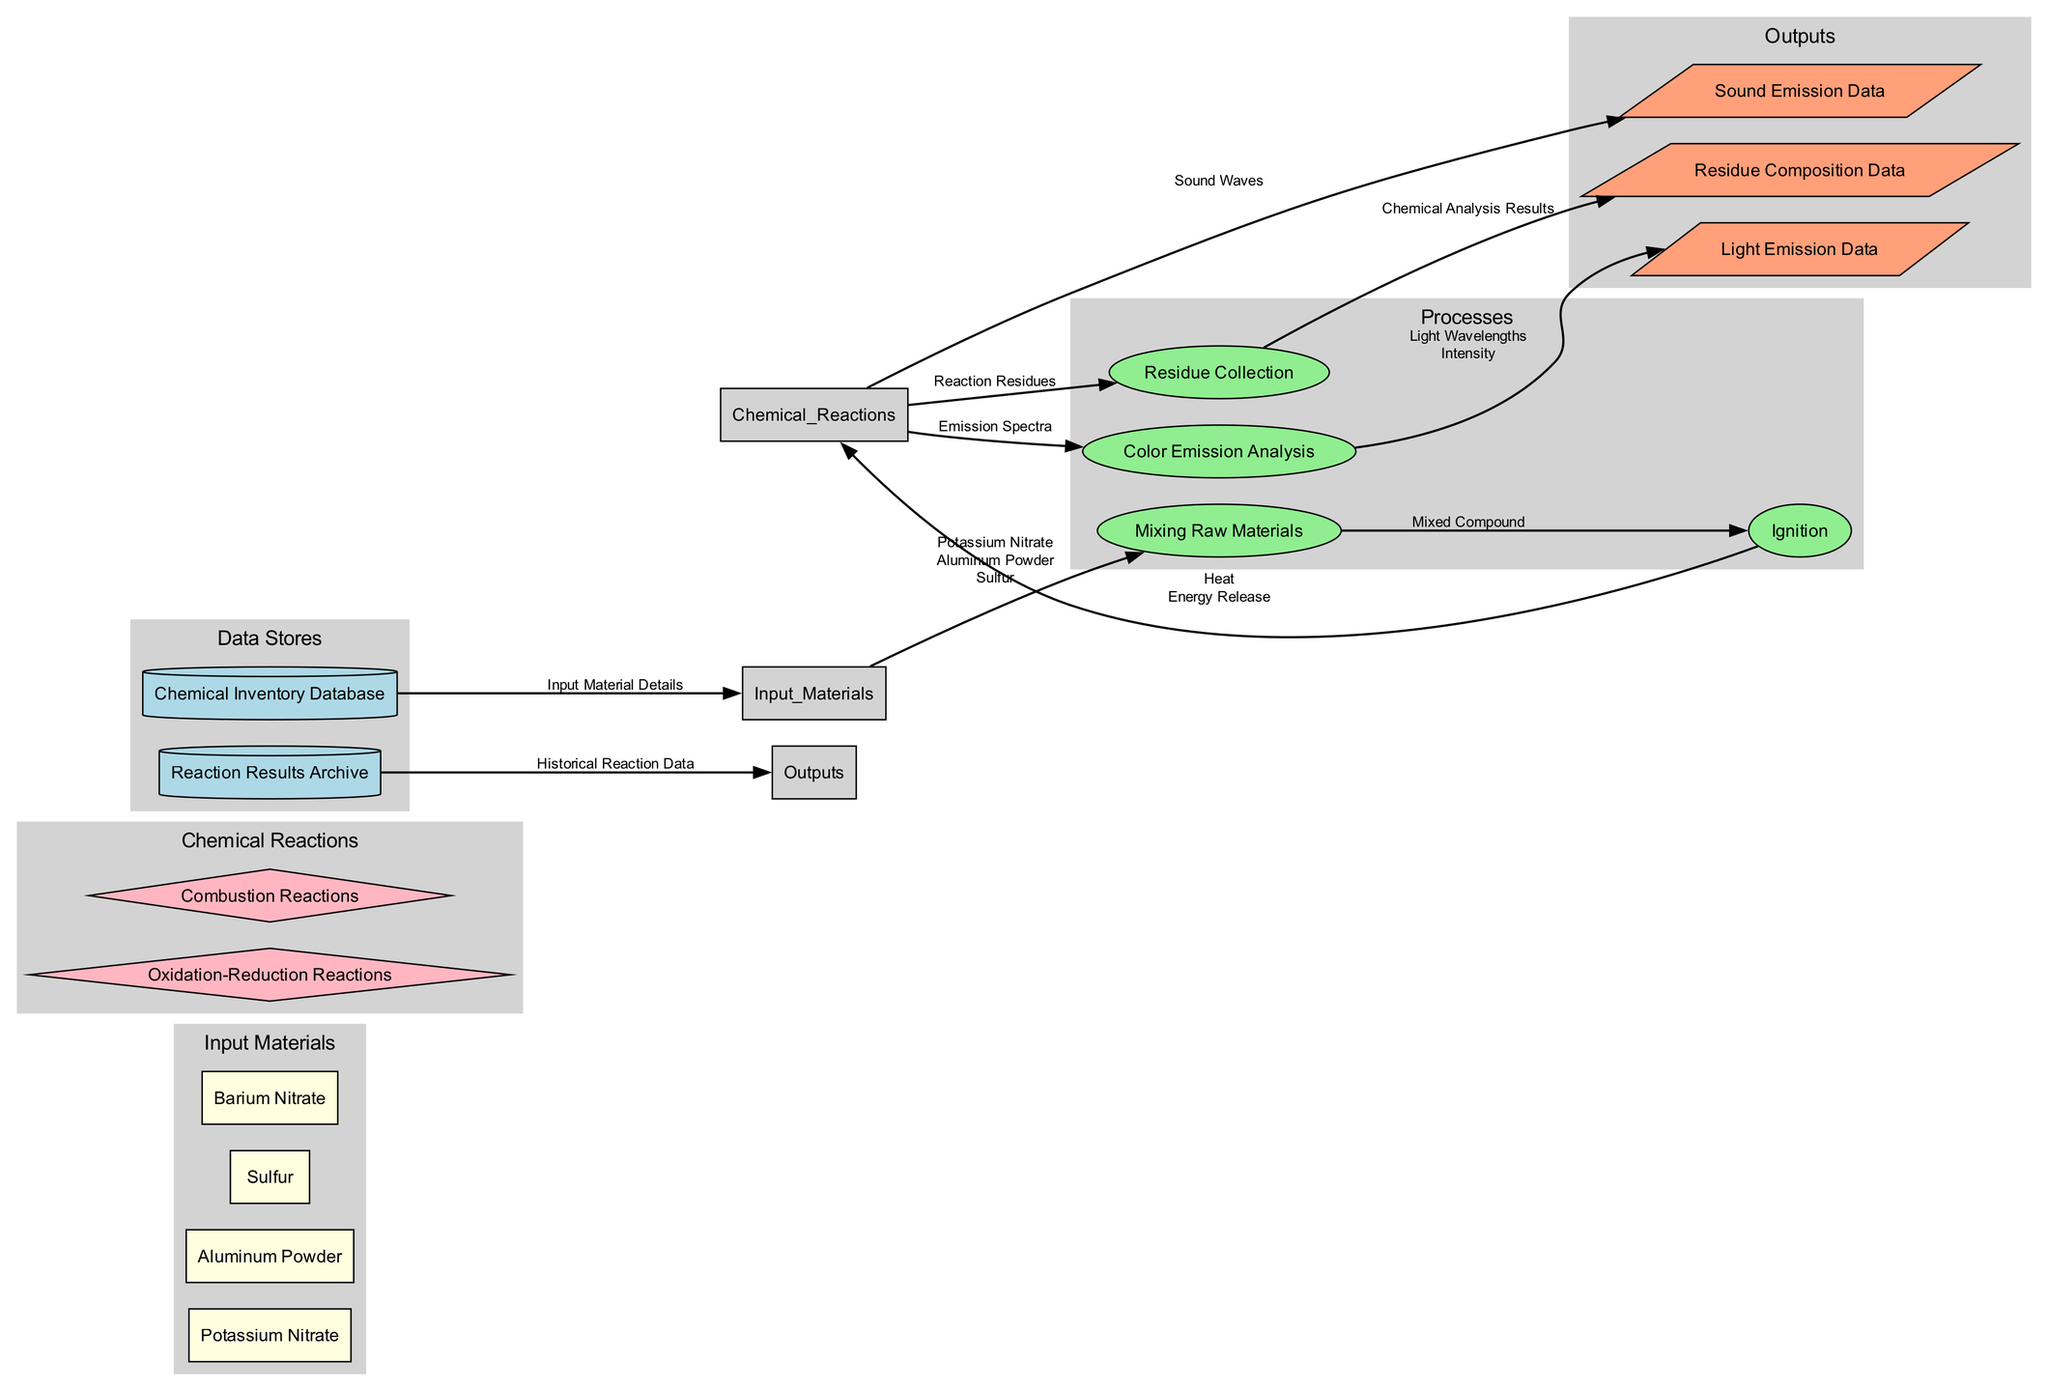What are the input materials used in the fireworks process? The diagram shows four input materials listed as "Potassium Nitrate," "Aluminum Powder," "Sulfur," and "Barium Nitrate" under the Input Materials section.
Answer: Potassium Nitrate, Aluminum Powder, Sulfur, Barium Nitrate Which process comes after "Mixing Raw Materials"? The flow from "Mixing Raw Materials" leads directly to "Ignition," indicating that ignition is the next step after mixing.
Answer: Ignition How many outputs are produced from the chemical reactions? The diagram lists three outputs: "Light Emission Data," "Sound Emission Data," and "Residue Composition Data." Therefore, there are three unique output paths stemming from the reactions.
Answer: Three What kind of data is not stored in the Chemical Inventory Database? The Chemical Inventory Database contains "Input Material Details," which means any data regarding reactions or outputs is not stored there. The outputs are stored in the Reaction Results Archive instead.
Answer: Reaction results What type of chemical reactions are analyzed in this workflow? The diagram includes "Oxidation-Reduction Reactions" and "Combustion Reactions" as the types of chemical reactions involved, providing the specific categories of reactions being analyzed in the fireworks process.
Answer: Oxidation-Reduction Reactions, Combustion Reactions How do "Chemical Reactions" contribute to "Sound Emission Data"? According to the diagram, "Chemical Reactions" provide data labeled "Sound Waves" that flows directly to the "Sound Emission Data," indicating the direct relationship between the two processes.
Answer: Sound Waves What is the resulting data of "Residue Collection"? The flow from "Residue Collection" to "Residue Composition Data" indicates that the final output from this process is composed of "Chemical Analysis Results." This means the data collected from residues is analyzed and stored as composition data.
Answer: Chemical Analysis Results How many processes are described in the diagram? The diagram indicates four distinct processes: "Mixing Raw Materials," "Ignition," "Color Emission Analysis," and "Residue Collection," confirming that there are four unique processing stages illustrated.
Answer: Four 